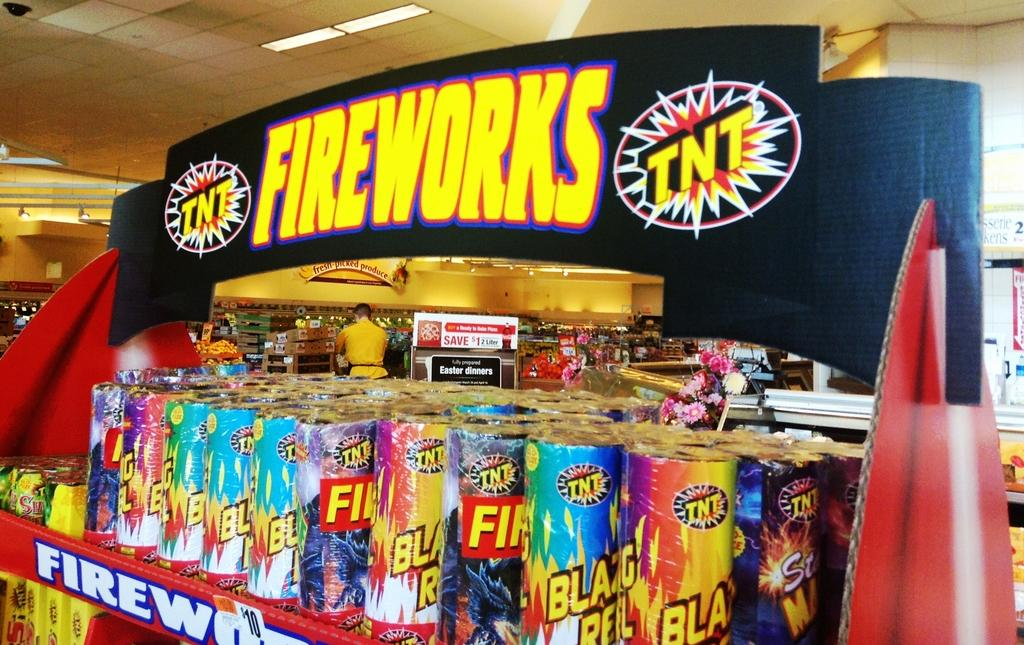<image>
Share a concise interpretation of the image provided. A display of fireworks is full, from the TNT company. 